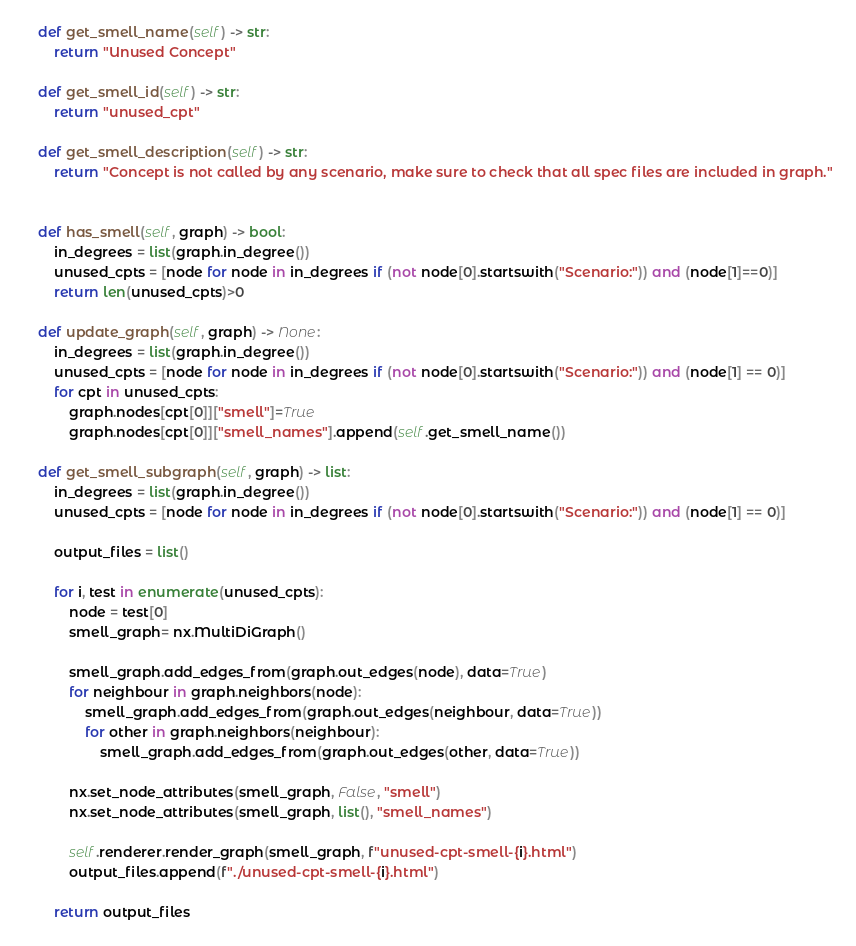<code> <loc_0><loc_0><loc_500><loc_500><_Python_>
    def get_smell_name(self) -> str:
        return "Unused Concept"

    def get_smell_id(self) -> str:
        return "unused_cpt"

    def get_smell_description(self) -> str:
        return "Concept is not called by any scenario, make sure to check that all spec files are included in graph."


    def has_smell(self, graph) -> bool:
        in_degrees = list(graph.in_degree())
        unused_cpts = [node for node in in_degrees if (not node[0].startswith("Scenario:")) and (node[1]==0)]
        return len(unused_cpts)>0

    def update_graph(self, graph) -> None:
        in_degrees = list(graph.in_degree())
        unused_cpts = [node for node in in_degrees if (not node[0].startswith("Scenario:")) and (node[1] == 0)]
        for cpt in unused_cpts:
            graph.nodes[cpt[0]]["smell"]=True
            graph.nodes[cpt[0]]["smell_names"].append(self.get_smell_name())

    def get_smell_subgraph(self, graph) -> list:
        in_degrees = list(graph.in_degree())
        unused_cpts = [node for node in in_degrees if (not node[0].startswith("Scenario:")) and (node[1] == 0)]

        output_files = list()

        for i, test in enumerate(unused_cpts):
            node = test[0]
            smell_graph= nx.MultiDiGraph()

            smell_graph.add_edges_from(graph.out_edges(node), data=True)
            for neighbour in graph.neighbors(node):
                smell_graph.add_edges_from(graph.out_edges(neighbour, data=True))
                for other in graph.neighbors(neighbour):
                    smell_graph.add_edges_from(graph.out_edges(other, data=True))

            nx.set_node_attributes(smell_graph, False, "smell")
            nx.set_node_attributes(smell_graph, list(), "smell_names")

            self.renderer.render_graph(smell_graph, f"unused-cpt-smell-{i}.html")
            output_files.append(f"./unused-cpt-smell-{i}.html")

        return output_files
</code> 